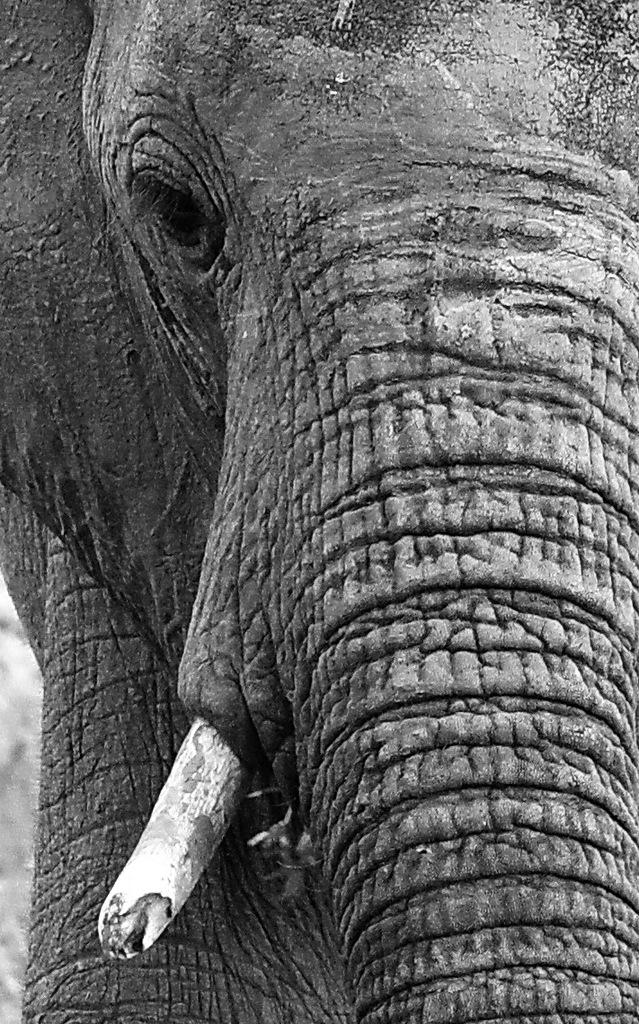What animal is the main subject of the image? There is an elephant in the image. Can you describe the background of the image? The background of the image is blurry. What type of scarf is the elephant wearing in the image? There is no scarf present in the image; the elephant is not wearing any clothing. How many cats can be seen interacting with the elephant in the image? There are no cats present in the image; the main subject is the elephant. 